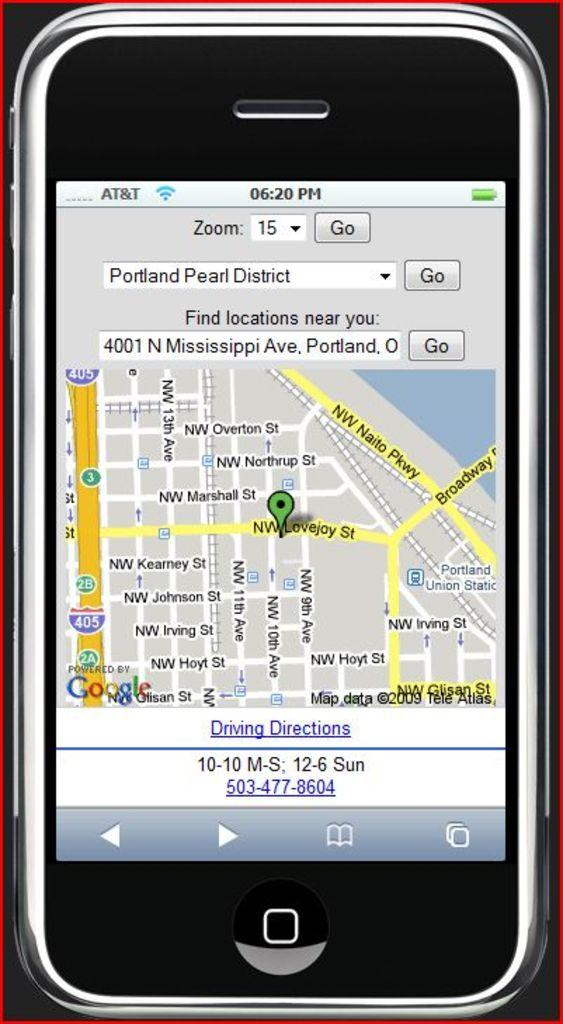Provide a one-sentence caption for the provided image. An iphone is displaying a mapped route from Portlands pearl district to Mississippi Ave in Portland. 